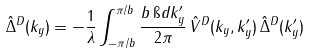Convert formula to latex. <formula><loc_0><loc_0><loc_500><loc_500>\hat { \Delta } ^ { D } ( k _ { y } ) = - \frac { 1 } { \lambda } \int _ { - \pi / b } ^ { \pi / b } \frac { b \, \i d k _ { y } ^ { \prime } } { 2 \pi } \, \hat { V } ^ { D } ( k _ { y } , k _ { y } ^ { \prime } ) \, \hat { \Delta } ^ { D } ( k _ { y } ^ { \prime } )</formula> 